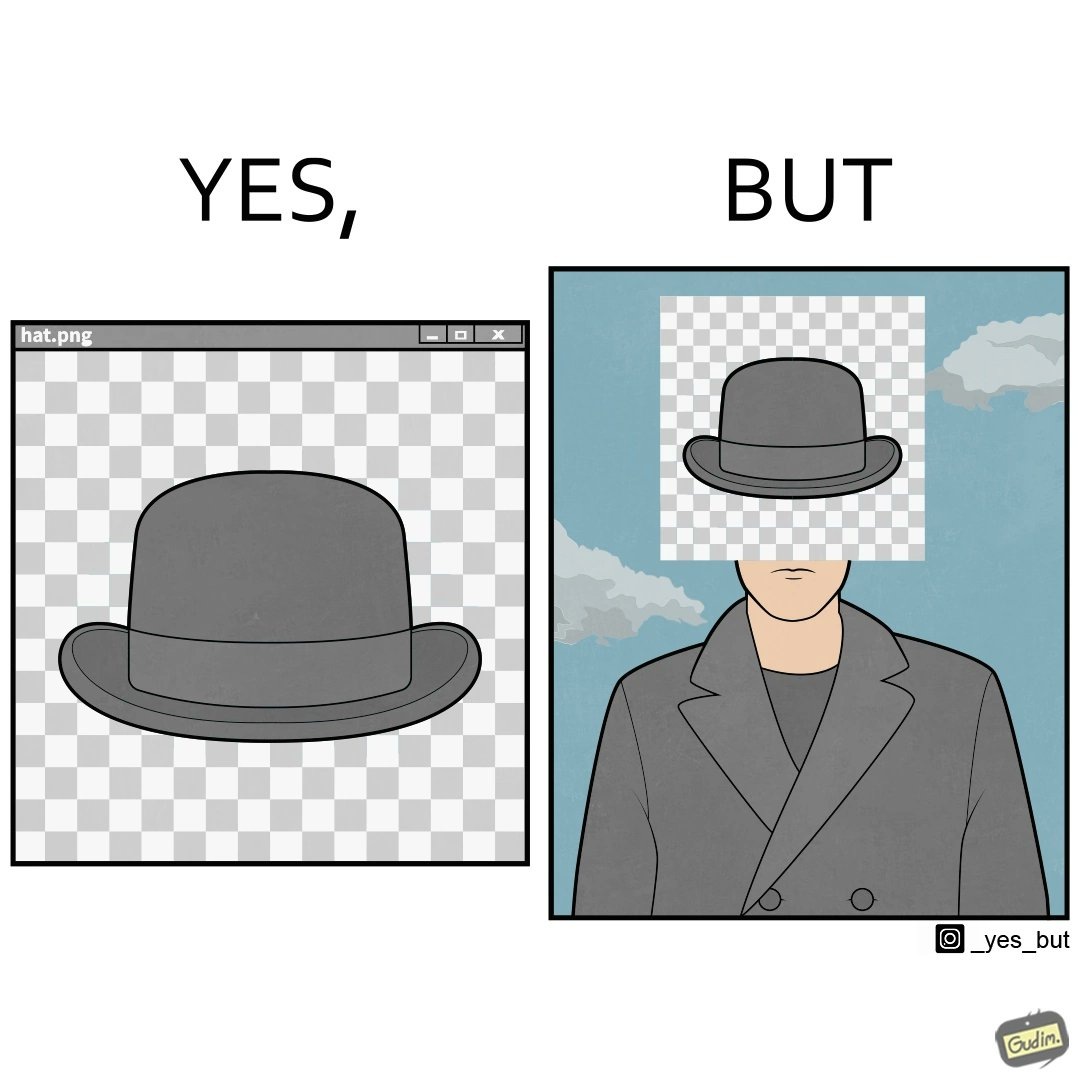What do you see in each half of this image? In the left part of the image: It is a .png image of a hat with a transparent background In the right part of the image: It is a man with a hat whose face is covered by a pattern 